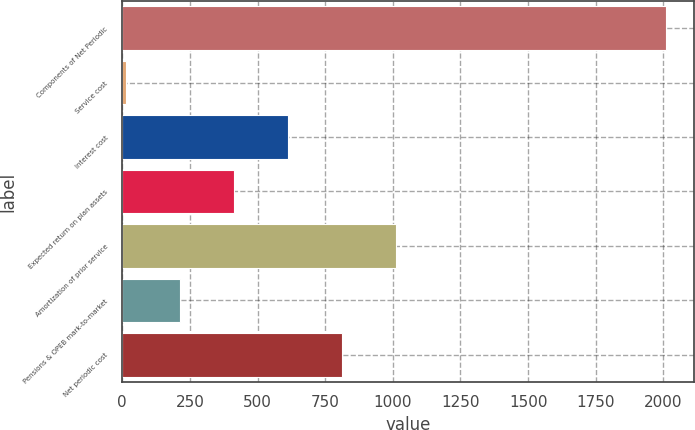Convert chart. <chart><loc_0><loc_0><loc_500><loc_500><bar_chart><fcel>Components of Net Periodic<fcel>Service cost<fcel>Interest cost<fcel>Expected return on plan assets<fcel>Amortization of prior service<fcel>Pensions & OPEB mark-to-market<fcel>Net periodic cost<nl><fcel>2011<fcel>13<fcel>612.4<fcel>412.6<fcel>1012<fcel>212.8<fcel>812.2<nl></chart> 